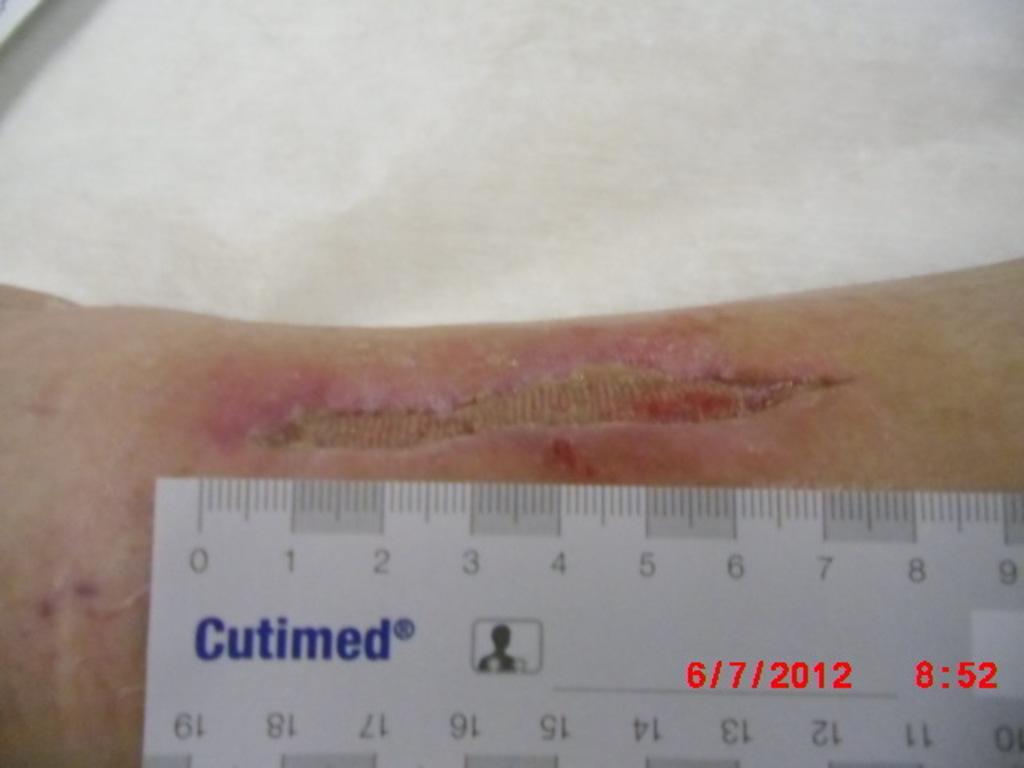Please provide a concise description of this image. In this image there is a scale ruler on an injured body part, at the bottom of the image there is a date and time. 